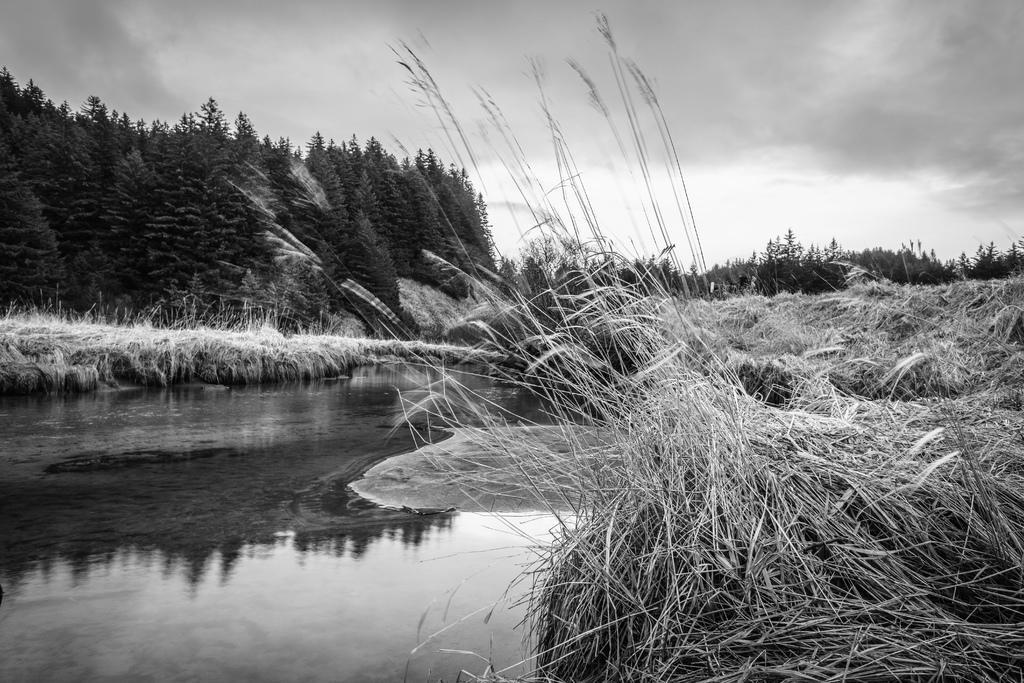Please provide a concise description of this image. In this picture I can observe a pond on the left side. I can observe some grass on the right side. In the background there are trees and clouds in the sky. 